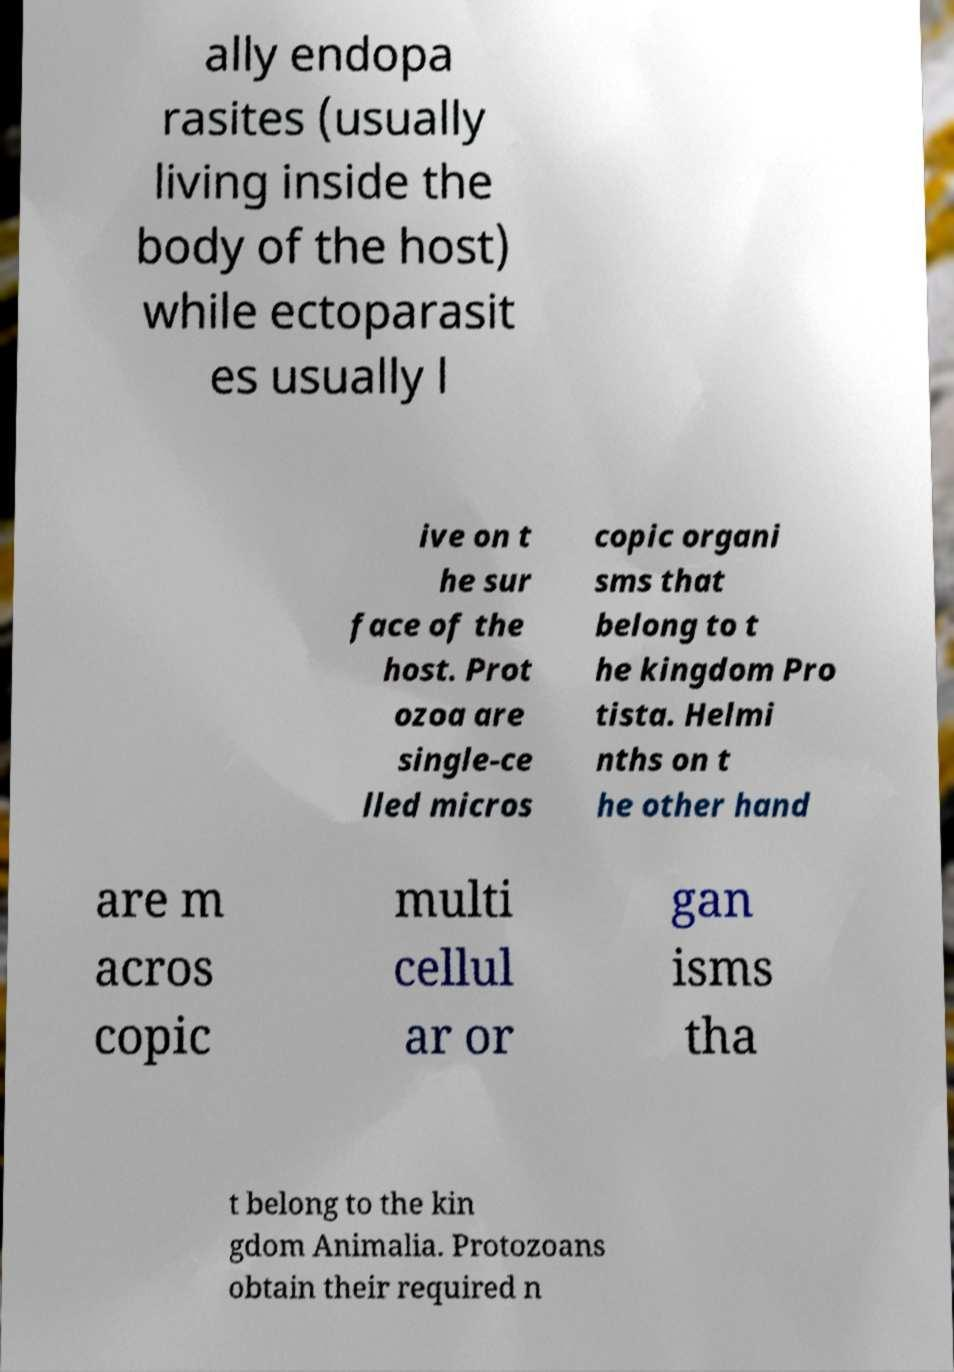Please identify and transcribe the text found in this image. ally endopa rasites (usually living inside the body of the host) while ectoparasit es usually l ive on t he sur face of the host. Prot ozoa are single-ce lled micros copic organi sms that belong to t he kingdom Pro tista. Helmi nths on t he other hand are m acros copic multi cellul ar or gan isms tha t belong to the kin gdom Animalia. Protozoans obtain their required n 